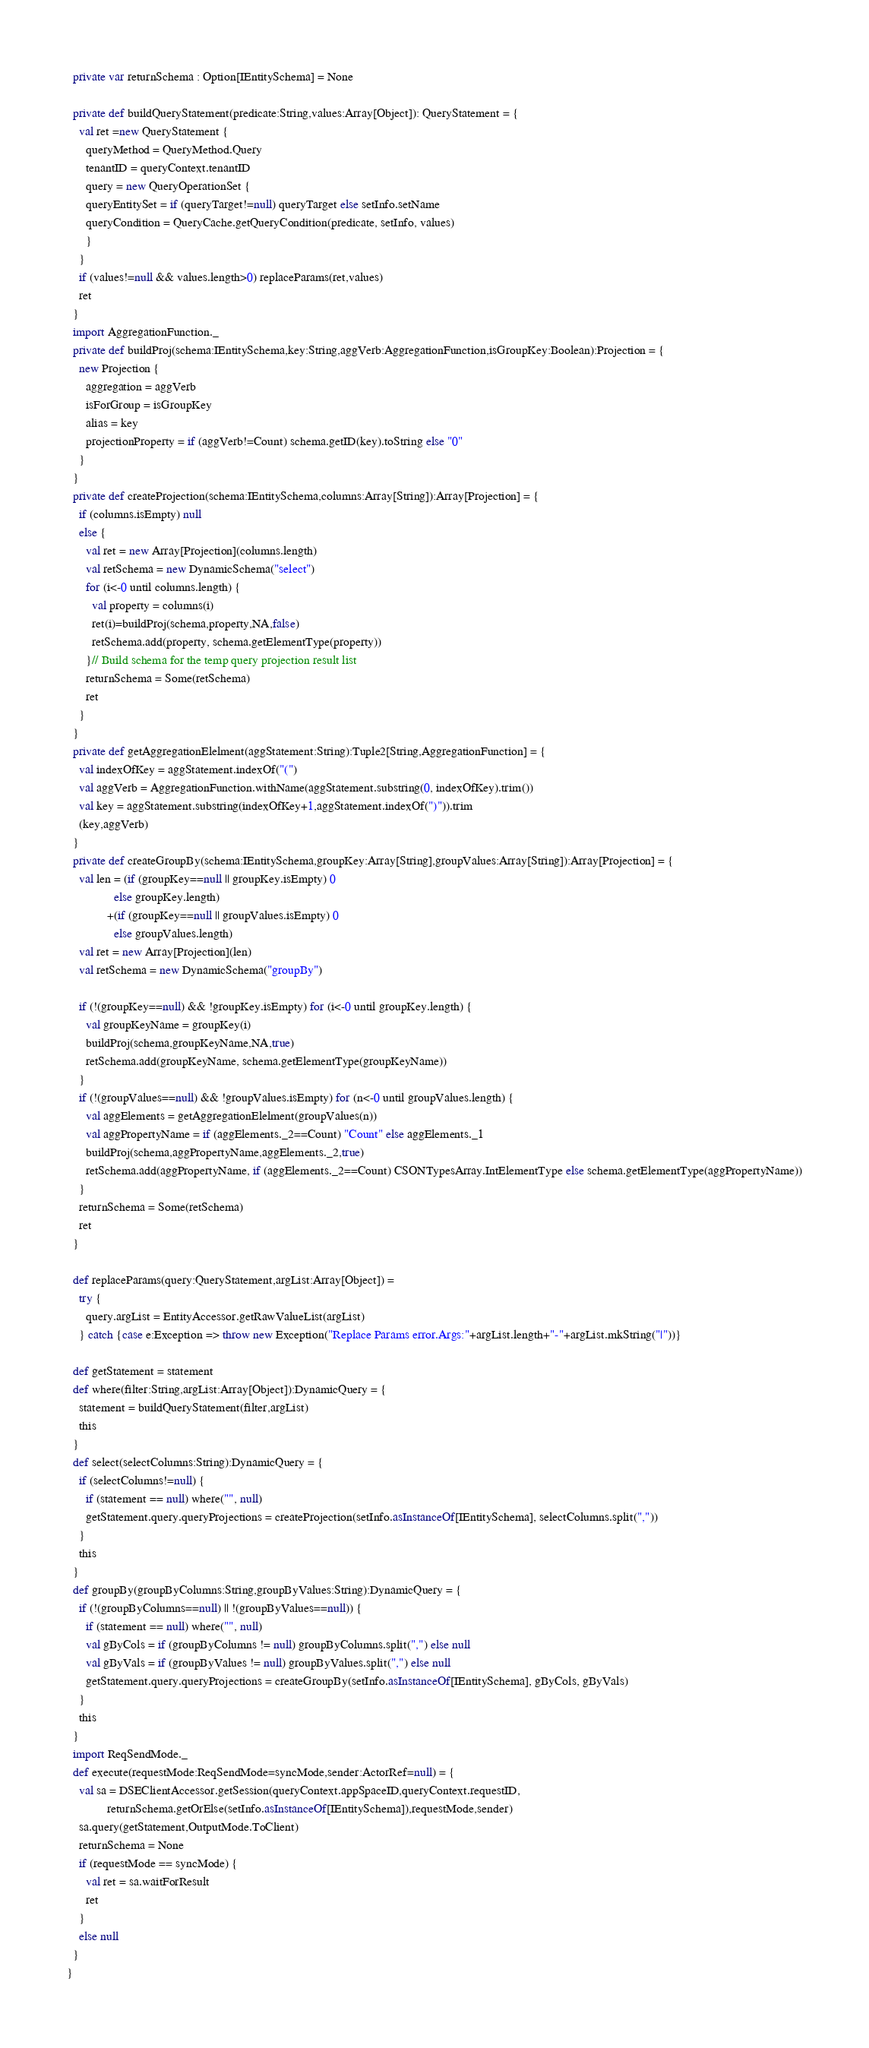Convert code to text. <code><loc_0><loc_0><loc_500><loc_500><_Scala_>  private var returnSchema : Option[IEntitySchema] = None
  
  private def buildQueryStatement(predicate:String,values:Array[Object]): QueryStatement = {
    val ret =new QueryStatement {
      queryMethod = QueryMethod.Query
      tenantID = queryContext.tenantID
      query = new QueryOperationSet {
      queryEntitySet = if (queryTarget!=null) queryTarget else setInfo.setName
      queryCondition = QueryCache.getQueryCondition(predicate, setInfo, values)
      }
    }
    if (values!=null && values.length>0) replaceParams(ret,values)
    ret
  }
  import AggregationFunction._
  private def buildProj(schema:IEntitySchema,key:String,aggVerb:AggregationFunction,isGroupKey:Boolean):Projection = {
    new Projection {
      aggregation = aggVerb
      isForGroup = isGroupKey
      alias = key
      projectionProperty = if (aggVerb!=Count) schema.getID(key).toString else "0"
    }
  }
  private def createProjection(schema:IEntitySchema,columns:Array[String]):Array[Projection] = {
    if (columns.isEmpty) null
    else {
      val ret = new Array[Projection](columns.length)
      val retSchema = new DynamicSchema("select")
      for (i<-0 until columns.length) {
        val property = columns(i)
        ret(i)=buildProj(schema,property,NA,false)
        retSchema.add(property, schema.getElementType(property))
      }// Build schema for the temp query projection result list
      returnSchema = Some(retSchema)
      ret
    }
  }
  private def getAggregationElelment(aggStatement:String):Tuple2[String,AggregationFunction] = {
    val indexOfKey = aggStatement.indexOf("(")
    val aggVerb = AggregationFunction.withName(aggStatement.substring(0, indexOfKey).trim())
    val key = aggStatement.substring(indexOfKey+1,aggStatement.indexOf(")")).trim
    (key,aggVerb)
  }
  private def createGroupBy(schema:IEntitySchema,groupKey:Array[String],groupValues:Array[String]):Array[Projection] = {
    val len = (if (groupKey==null || groupKey.isEmpty) 0
               else groupKey.length)
             +(if (groupKey==null || groupValues.isEmpty) 0
               else groupValues.length)
    val ret = new Array[Projection](len)
    val retSchema = new DynamicSchema("groupBy")
    
    if (!(groupKey==null) && !groupKey.isEmpty) for (i<-0 until groupKey.length) {
      val groupKeyName = groupKey(i)
      buildProj(schema,groupKeyName,NA,true)
      retSchema.add(groupKeyName, schema.getElementType(groupKeyName))
    }
    if (!(groupValues==null) && !groupValues.isEmpty) for (n<-0 until groupValues.length) {
      val aggElements = getAggregationElelment(groupValues(n))
      val aggPropertyName = if (aggElements._2==Count) "Count" else aggElements._1
      buildProj(schema,aggPropertyName,aggElements._2,true)
      retSchema.add(aggPropertyName, if (aggElements._2==Count) CSONTypesArray.IntElementType else schema.getElementType(aggPropertyName))
    }
    returnSchema = Some(retSchema)
    ret
  }
  
  def replaceParams(query:QueryStatement,argList:Array[Object]) =
    try {
      query.argList = EntityAccessor.getRawValueList(argList)
    } catch {case e:Exception => throw new Exception("Replace Params error.Args:"+argList.length+"-"+argList.mkString("|"))}
  
  def getStatement = statement
  def where(filter:String,argList:Array[Object]):DynamicQuery = { 
    statement = buildQueryStatement(filter,argList)
    this
  }
  def select(selectColumns:String):DynamicQuery = {
    if (selectColumns!=null) {
      if (statement == null) where("", null)
      getStatement.query.queryProjections = createProjection(setInfo.asInstanceOf[IEntitySchema], selectColumns.split(","))
    }
    this
  }
  def groupBy(groupByColumns:String,groupByValues:String):DynamicQuery = {
    if (!(groupByColumns==null) || !(groupByValues==null)) {
      if (statement == null) where("", null)
      val gByCols = if (groupByColumns != null) groupByColumns.split(",") else null
      val gByVals = if (groupByValues != null) groupByValues.split(",") else null
      getStatement.query.queryProjections = createGroupBy(setInfo.asInstanceOf[IEntitySchema], gByCols, gByVals)
    }
    this
  }
  import ReqSendMode._
  def execute(requestMode:ReqSendMode=syncMode,sender:ActorRef=null) = {
    val sa = DSEClientAccessor.getSession(queryContext.appSpaceID,queryContext.requestID,
             returnSchema.getOrElse(setInfo.asInstanceOf[IEntitySchema]),requestMode,sender)
    sa.query(getStatement,OutputMode.ToClient)
    returnSchema = None
    if (requestMode == syncMode) {
      val ret = sa.waitForResult
      ret
    }
    else null
  }
}
</code> 